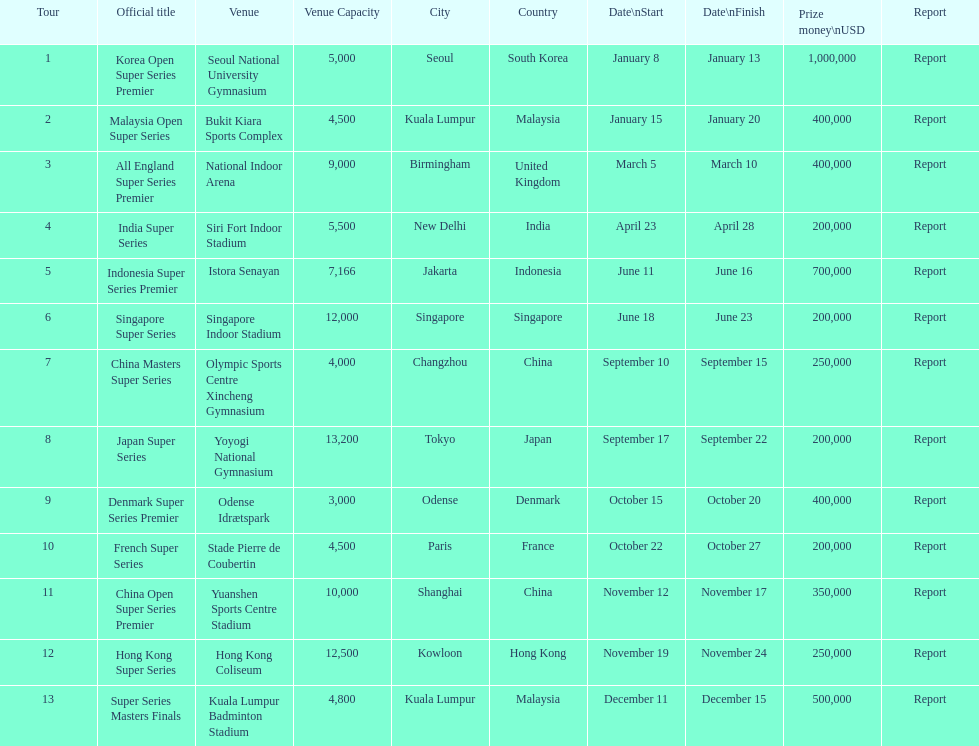How many series awarded at least $500,000 in prize money? 3. 